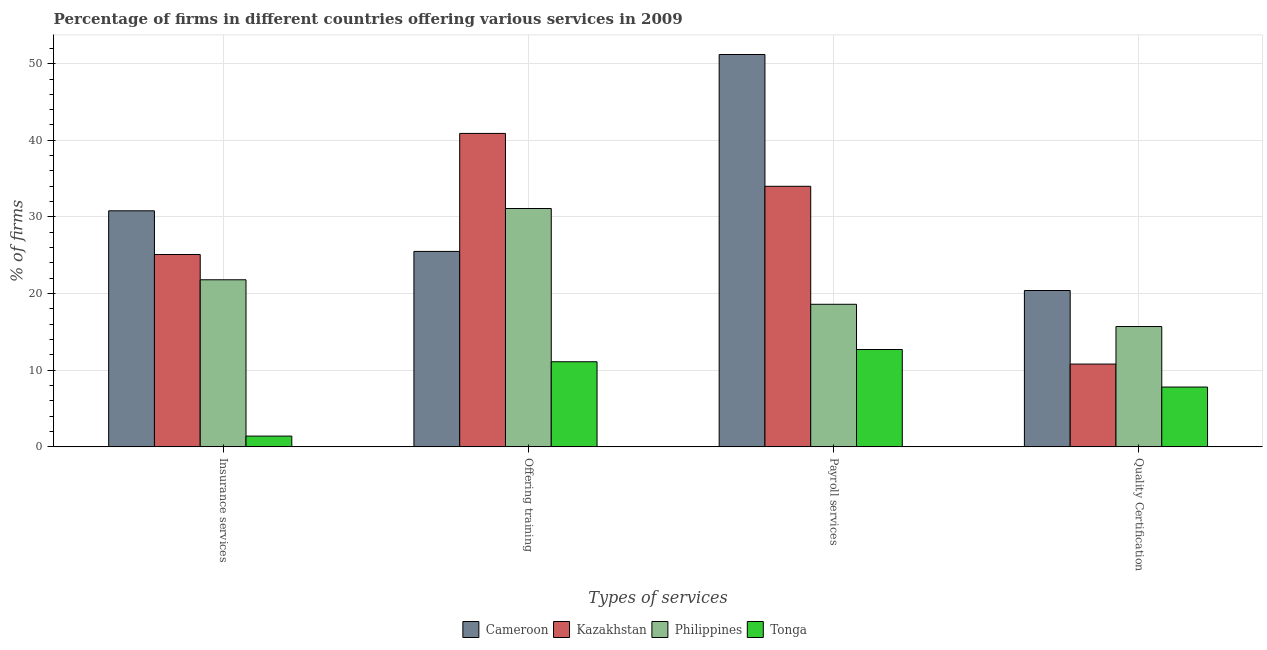How many groups of bars are there?
Provide a succinct answer. 4. Are the number of bars on each tick of the X-axis equal?
Give a very brief answer. Yes. How many bars are there on the 1st tick from the right?
Your answer should be very brief. 4. What is the label of the 3rd group of bars from the left?
Provide a succinct answer. Payroll services. What is the percentage of firms offering quality certification in Kazakhstan?
Give a very brief answer. 10.8. Across all countries, what is the maximum percentage of firms offering quality certification?
Keep it short and to the point. 20.4. Across all countries, what is the minimum percentage of firms offering insurance services?
Give a very brief answer. 1.4. In which country was the percentage of firms offering quality certification maximum?
Your answer should be compact. Cameroon. In which country was the percentage of firms offering payroll services minimum?
Provide a short and direct response. Tonga. What is the total percentage of firms offering training in the graph?
Your answer should be very brief. 108.6. What is the difference between the percentage of firms offering quality certification in Cameroon and that in Philippines?
Ensure brevity in your answer.  4.7. What is the difference between the percentage of firms offering payroll services in Philippines and the percentage of firms offering quality certification in Kazakhstan?
Keep it short and to the point. 7.8. What is the average percentage of firms offering quality certification per country?
Your response must be concise. 13.67. What is the difference between the percentage of firms offering insurance services and percentage of firms offering quality certification in Cameroon?
Your response must be concise. 10.4. In how many countries, is the percentage of firms offering insurance services greater than 38 %?
Ensure brevity in your answer.  0. What is the ratio of the percentage of firms offering quality certification in Kazakhstan to that in Tonga?
Give a very brief answer. 1.38. Is the difference between the percentage of firms offering quality certification in Kazakhstan and Tonga greater than the difference between the percentage of firms offering insurance services in Kazakhstan and Tonga?
Offer a very short reply. No. What is the difference between the highest and the second highest percentage of firms offering quality certification?
Give a very brief answer. 4.7. What is the difference between the highest and the lowest percentage of firms offering insurance services?
Provide a succinct answer. 29.4. In how many countries, is the percentage of firms offering training greater than the average percentage of firms offering training taken over all countries?
Offer a terse response. 2. Is the sum of the percentage of firms offering quality certification in Tonga and Cameroon greater than the maximum percentage of firms offering training across all countries?
Provide a short and direct response. No. What does the 3rd bar from the left in Payroll services represents?
Ensure brevity in your answer.  Philippines. What does the 4th bar from the right in Offering training represents?
Offer a terse response. Cameroon. Is it the case that in every country, the sum of the percentage of firms offering insurance services and percentage of firms offering training is greater than the percentage of firms offering payroll services?
Offer a very short reply. No. How many bars are there?
Your response must be concise. 16. How many countries are there in the graph?
Provide a short and direct response. 4. Does the graph contain any zero values?
Provide a succinct answer. No. Does the graph contain grids?
Your response must be concise. Yes. Where does the legend appear in the graph?
Your answer should be compact. Bottom center. What is the title of the graph?
Offer a very short reply. Percentage of firms in different countries offering various services in 2009. What is the label or title of the X-axis?
Ensure brevity in your answer.  Types of services. What is the label or title of the Y-axis?
Offer a very short reply. % of firms. What is the % of firms of Cameroon in Insurance services?
Provide a short and direct response. 30.8. What is the % of firms of Kazakhstan in Insurance services?
Give a very brief answer. 25.1. What is the % of firms in Philippines in Insurance services?
Your answer should be very brief. 21.8. What is the % of firms of Cameroon in Offering training?
Keep it short and to the point. 25.5. What is the % of firms of Kazakhstan in Offering training?
Provide a short and direct response. 40.9. What is the % of firms in Philippines in Offering training?
Provide a short and direct response. 31.1. What is the % of firms in Tonga in Offering training?
Provide a succinct answer. 11.1. What is the % of firms in Cameroon in Payroll services?
Your answer should be compact. 51.2. What is the % of firms in Kazakhstan in Payroll services?
Offer a very short reply. 34. What is the % of firms in Philippines in Payroll services?
Ensure brevity in your answer.  18.6. What is the % of firms in Tonga in Payroll services?
Provide a succinct answer. 12.7. What is the % of firms of Cameroon in Quality Certification?
Provide a short and direct response. 20.4. What is the % of firms of Tonga in Quality Certification?
Offer a terse response. 7.8. Across all Types of services, what is the maximum % of firms of Cameroon?
Keep it short and to the point. 51.2. Across all Types of services, what is the maximum % of firms of Kazakhstan?
Offer a terse response. 40.9. Across all Types of services, what is the maximum % of firms in Philippines?
Provide a short and direct response. 31.1. Across all Types of services, what is the maximum % of firms of Tonga?
Offer a terse response. 12.7. Across all Types of services, what is the minimum % of firms in Cameroon?
Your answer should be compact. 20.4. Across all Types of services, what is the minimum % of firms of Kazakhstan?
Your answer should be very brief. 10.8. What is the total % of firms in Cameroon in the graph?
Your response must be concise. 127.9. What is the total % of firms in Kazakhstan in the graph?
Your response must be concise. 110.8. What is the total % of firms of Philippines in the graph?
Make the answer very short. 87.2. What is the total % of firms of Tonga in the graph?
Offer a terse response. 33. What is the difference between the % of firms in Cameroon in Insurance services and that in Offering training?
Ensure brevity in your answer.  5.3. What is the difference between the % of firms in Kazakhstan in Insurance services and that in Offering training?
Keep it short and to the point. -15.8. What is the difference between the % of firms in Cameroon in Insurance services and that in Payroll services?
Provide a short and direct response. -20.4. What is the difference between the % of firms of Kazakhstan in Insurance services and that in Payroll services?
Offer a very short reply. -8.9. What is the difference between the % of firms of Philippines in Insurance services and that in Payroll services?
Provide a short and direct response. 3.2. What is the difference between the % of firms of Tonga in Insurance services and that in Payroll services?
Your answer should be very brief. -11.3. What is the difference between the % of firms in Tonga in Insurance services and that in Quality Certification?
Offer a terse response. -6.4. What is the difference between the % of firms of Cameroon in Offering training and that in Payroll services?
Your response must be concise. -25.7. What is the difference between the % of firms in Philippines in Offering training and that in Payroll services?
Your answer should be compact. 12.5. What is the difference between the % of firms in Tonga in Offering training and that in Payroll services?
Make the answer very short. -1.6. What is the difference between the % of firms of Cameroon in Offering training and that in Quality Certification?
Provide a short and direct response. 5.1. What is the difference between the % of firms of Kazakhstan in Offering training and that in Quality Certification?
Provide a succinct answer. 30.1. What is the difference between the % of firms of Philippines in Offering training and that in Quality Certification?
Offer a terse response. 15.4. What is the difference between the % of firms in Cameroon in Payroll services and that in Quality Certification?
Keep it short and to the point. 30.8. What is the difference between the % of firms in Kazakhstan in Payroll services and that in Quality Certification?
Your answer should be compact. 23.2. What is the difference between the % of firms in Tonga in Payroll services and that in Quality Certification?
Keep it short and to the point. 4.9. What is the difference between the % of firms of Cameroon in Insurance services and the % of firms of Kazakhstan in Offering training?
Your response must be concise. -10.1. What is the difference between the % of firms of Kazakhstan in Insurance services and the % of firms of Philippines in Offering training?
Give a very brief answer. -6. What is the difference between the % of firms of Philippines in Insurance services and the % of firms of Tonga in Offering training?
Provide a short and direct response. 10.7. What is the difference between the % of firms of Cameroon in Insurance services and the % of firms of Philippines in Payroll services?
Provide a short and direct response. 12.2. What is the difference between the % of firms in Kazakhstan in Insurance services and the % of firms in Philippines in Payroll services?
Your answer should be compact. 6.5. What is the difference between the % of firms in Cameroon in Insurance services and the % of firms in Kazakhstan in Quality Certification?
Your answer should be compact. 20. What is the difference between the % of firms of Cameroon in Insurance services and the % of firms of Philippines in Quality Certification?
Provide a succinct answer. 15.1. What is the difference between the % of firms in Kazakhstan in Insurance services and the % of firms in Philippines in Quality Certification?
Provide a short and direct response. 9.4. What is the difference between the % of firms in Kazakhstan in Insurance services and the % of firms in Tonga in Quality Certification?
Offer a terse response. 17.3. What is the difference between the % of firms in Philippines in Insurance services and the % of firms in Tonga in Quality Certification?
Your response must be concise. 14. What is the difference between the % of firms of Cameroon in Offering training and the % of firms of Kazakhstan in Payroll services?
Ensure brevity in your answer.  -8.5. What is the difference between the % of firms of Cameroon in Offering training and the % of firms of Philippines in Payroll services?
Keep it short and to the point. 6.9. What is the difference between the % of firms of Kazakhstan in Offering training and the % of firms of Philippines in Payroll services?
Offer a terse response. 22.3. What is the difference between the % of firms in Kazakhstan in Offering training and the % of firms in Tonga in Payroll services?
Offer a terse response. 28.2. What is the difference between the % of firms in Philippines in Offering training and the % of firms in Tonga in Payroll services?
Provide a short and direct response. 18.4. What is the difference between the % of firms of Cameroon in Offering training and the % of firms of Kazakhstan in Quality Certification?
Offer a terse response. 14.7. What is the difference between the % of firms in Cameroon in Offering training and the % of firms in Philippines in Quality Certification?
Keep it short and to the point. 9.8. What is the difference between the % of firms in Kazakhstan in Offering training and the % of firms in Philippines in Quality Certification?
Your answer should be very brief. 25.2. What is the difference between the % of firms of Kazakhstan in Offering training and the % of firms of Tonga in Quality Certification?
Offer a very short reply. 33.1. What is the difference between the % of firms in Philippines in Offering training and the % of firms in Tonga in Quality Certification?
Make the answer very short. 23.3. What is the difference between the % of firms of Cameroon in Payroll services and the % of firms of Kazakhstan in Quality Certification?
Your answer should be compact. 40.4. What is the difference between the % of firms of Cameroon in Payroll services and the % of firms of Philippines in Quality Certification?
Your answer should be compact. 35.5. What is the difference between the % of firms in Cameroon in Payroll services and the % of firms in Tonga in Quality Certification?
Your response must be concise. 43.4. What is the difference between the % of firms of Kazakhstan in Payroll services and the % of firms of Philippines in Quality Certification?
Give a very brief answer. 18.3. What is the difference between the % of firms of Kazakhstan in Payroll services and the % of firms of Tonga in Quality Certification?
Provide a short and direct response. 26.2. What is the difference between the % of firms in Philippines in Payroll services and the % of firms in Tonga in Quality Certification?
Your response must be concise. 10.8. What is the average % of firms in Cameroon per Types of services?
Your answer should be compact. 31.98. What is the average % of firms in Kazakhstan per Types of services?
Give a very brief answer. 27.7. What is the average % of firms of Philippines per Types of services?
Offer a terse response. 21.8. What is the average % of firms in Tonga per Types of services?
Your response must be concise. 8.25. What is the difference between the % of firms of Cameroon and % of firms of Kazakhstan in Insurance services?
Offer a very short reply. 5.7. What is the difference between the % of firms in Cameroon and % of firms in Tonga in Insurance services?
Offer a terse response. 29.4. What is the difference between the % of firms of Kazakhstan and % of firms of Philippines in Insurance services?
Your answer should be very brief. 3.3. What is the difference between the % of firms of Kazakhstan and % of firms of Tonga in Insurance services?
Provide a succinct answer. 23.7. What is the difference between the % of firms of Philippines and % of firms of Tonga in Insurance services?
Give a very brief answer. 20.4. What is the difference between the % of firms of Cameroon and % of firms of Kazakhstan in Offering training?
Your answer should be very brief. -15.4. What is the difference between the % of firms of Kazakhstan and % of firms of Philippines in Offering training?
Make the answer very short. 9.8. What is the difference between the % of firms of Kazakhstan and % of firms of Tonga in Offering training?
Offer a terse response. 29.8. What is the difference between the % of firms in Cameroon and % of firms in Philippines in Payroll services?
Offer a very short reply. 32.6. What is the difference between the % of firms of Cameroon and % of firms of Tonga in Payroll services?
Your answer should be compact. 38.5. What is the difference between the % of firms of Kazakhstan and % of firms of Philippines in Payroll services?
Your response must be concise. 15.4. What is the difference between the % of firms in Kazakhstan and % of firms in Tonga in Payroll services?
Keep it short and to the point. 21.3. What is the difference between the % of firms in Philippines and % of firms in Tonga in Payroll services?
Provide a short and direct response. 5.9. What is the difference between the % of firms of Cameroon and % of firms of Philippines in Quality Certification?
Your answer should be very brief. 4.7. What is the difference between the % of firms in Cameroon and % of firms in Tonga in Quality Certification?
Make the answer very short. 12.6. What is the difference between the % of firms in Kazakhstan and % of firms in Tonga in Quality Certification?
Provide a succinct answer. 3. What is the ratio of the % of firms in Cameroon in Insurance services to that in Offering training?
Give a very brief answer. 1.21. What is the ratio of the % of firms in Kazakhstan in Insurance services to that in Offering training?
Your answer should be compact. 0.61. What is the ratio of the % of firms of Philippines in Insurance services to that in Offering training?
Offer a very short reply. 0.7. What is the ratio of the % of firms of Tonga in Insurance services to that in Offering training?
Offer a terse response. 0.13. What is the ratio of the % of firms of Cameroon in Insurance services to that in Payroll services?
Give a very brief answer. 0.6. What is the ratio of the % of firms in Kazakhstan in Insurance services to that in Payroll services?
Keep it short and to the point. 0.74. What is the ratio of the % of firms in Philippines in Insurance services to that in Payroll services?
Your response must be concise. 1.17. What is the ratio of the % of firms in Tonga in Insurance services to that in Payroll services?
Your answer should be very brief. 0.11. What is the ratio of the % of firms in Cameroon in Insurance services to that in Quality Certification?
Give a very brief answer. 1.51. What is the ratio of the % of firms in Kazakhstan in Insurance services to that in Quality Certification?
Provide a succinct answer. 2.32. What is the ratio of the % of firms in Philippines in Insurance services to that in Quality Certification?
Offer a terse response. 1.39. What is the ratio of the % of firms in Tonga in Insurance services to that in Quality Certification?
Your answer should be compact. 0.18. What is the ratio of the % of firms of Cameroon in Offering training to that in Payroll services?
Provide a succinct answer. 0.5. What is the ratio of the % of firms in Kazakhstan in Offering training to that in Payroll services?
Keep it short and to the point. 1.2. What is the ratio of the % of firms in Philippines in Offering training to that in Payroll services?
Ensure brevity in your answer.  1.67. What is the ratio of the % of firms in Tonga in Offering training to that in Payroll services?
Keep it short and to the point. 0.87. What is the ratio of the % of firms in Kazakhstan in Offering training to that in Quality Certification?
Your answer should be very brief. 3.79. What is the ratio of the % of firms of Philippines in Offering training to that in Quality Certification?
Provide a succinct answer. 1.98. What is the ratio of the % of firms in Tonga in Offering training to that in Quality Certification?
Make the answer very short. 1.42. What is the ratio of the % of firms in Cameroon in Payroll services to that in Quality Certification?
Offer a terse response. 2.51. What is the ratio of the % of firms in Kazakhstan in Payroll services to that in Quality Certification?
Make the answer very short. 3.15. What is the ratio of the % of firms in Philippines in Payroll services to that in Quality Certification?
Make the answer very short. 1.18. What is the ratio of the % of firms in Tonga in Payroll services to that in Quality Certification?
Your answer should be compact. 1.63. What is the difference between the highest and the second highest % of firms in Cameroon?
Your answer should be very brief. 20.4. What is the difference between the highest and the second highest % of firms in Kazakhstan?
Ensure brevity in your answer.  6.9. What is the difference between the highest and the second highest % of firms in Philippines?
Provide a short and direct response. 9.3. What is the difference between the highest and the second highest % of firms in Tonga?
Ensure brevity in your answer.  1.6. What is the difference between the highest and the lowest % of firms of Cameroon?
Give a very brief answer. 30.8. What is the difference between the highest and the lowest % of firms in Kazakhstan?
Provide a succinct answer. 30.1. What is the difference between the highest and the lowest % of firms in Tonga?
Ensure brevity in your answer.  11.3. 